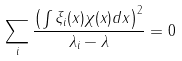Convert formula to latex. <formula><loc_0><loc_0><loc_500><loc_500>\sum _ { i } \frac { \left ( \int \xi _ { i } ( x ) \chi ( x ) d x \right ) ^ { 2 } } { \lambda _ { i } - \lambda } = 0</formula> 